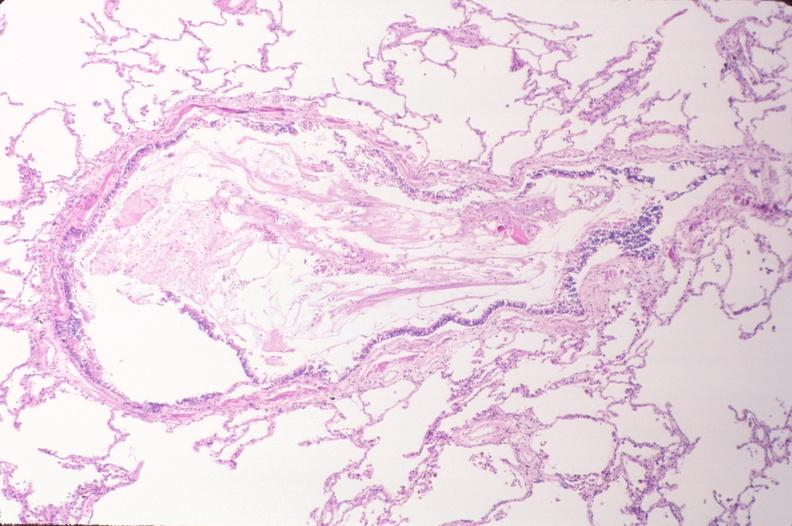what does this image show?
Answer the question using a single word or phrase. Lung 